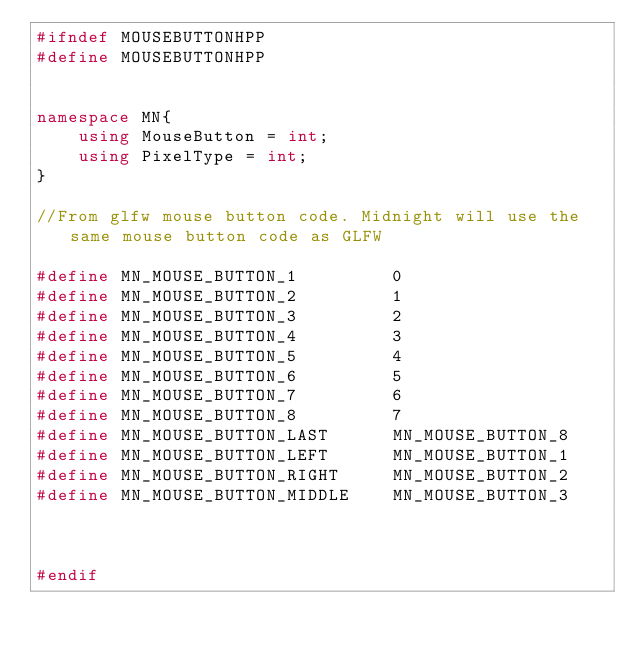<code> <loc_0><loc_0><loc_500><loc_500><_C++_>#ifndef MOUSEBUTTONHPP
#define MOUSEBUTTONHPP


namespace MN{
	using MouseButton = int;
	using PixelType = int;
}

//From glfw mouse button code. Midnight will use the same mouse button code as GLFW

#define MN_MOUSE_BUTTON_1         0
#define MN_MOUSE_BUTTON_2         1
#define MN_MOUSE_BUTTON_3         2
#define MN_MOUSE_BUTTON_4         3
#define MN_MOUSE_BUTTON_5         4
#define MN_MOUSE_BUTTON_6         5
#define MN_MOUSE_BUTTON_7         6
#define MN_MOUSE_BUTTON_8         7
#define MN_MOUSE_BUTTON_LAST      MN_MOUSE_BUTTON_8
#define MN_MOUSE_BUTTON_LEFT      MN_MOUSE_BUTTON_1
#define MN_MOUSE_BUTTON_RIGHT     MN_MOUSE_BUTTON_2
#define MN_MOUSE_BUTTON_MIDDLE    MN_MOUSE_BUTTON_3



#endif</code> 